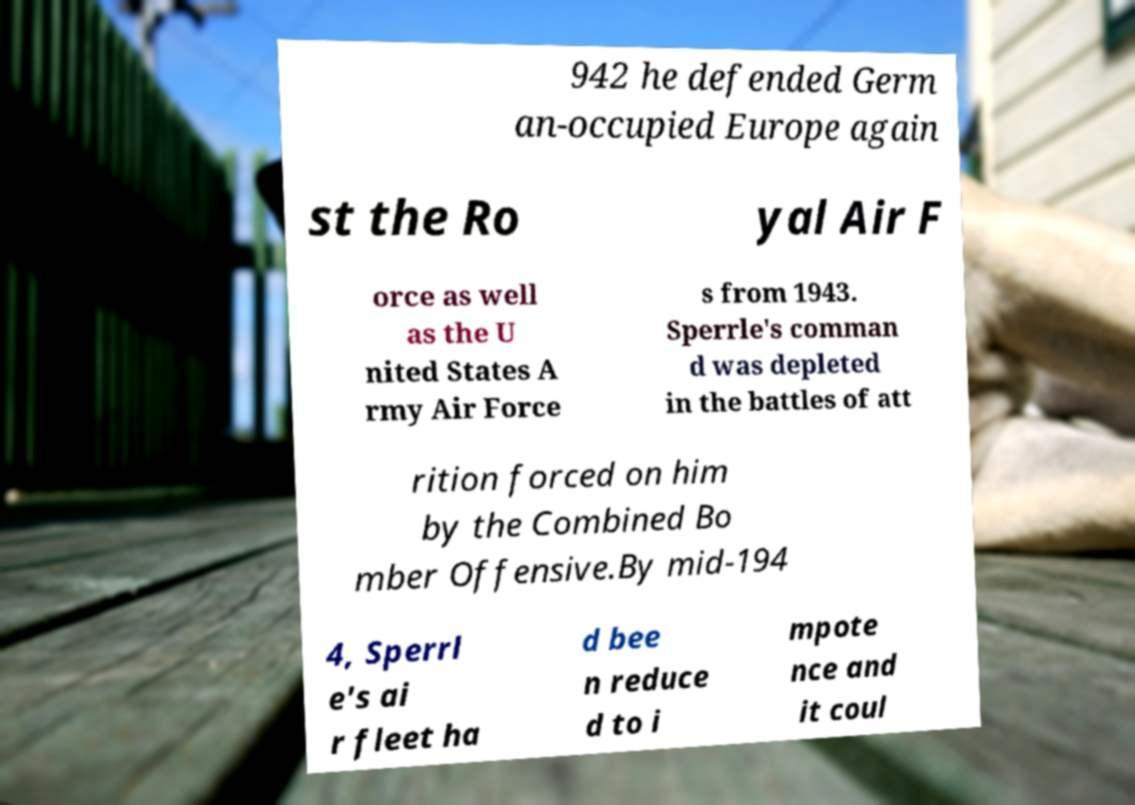I need the written content from this picture converted into text. Can you do that? 942 he defended Germ an-occupied Europe again st the Ro yal Air F orce as well as the U nited States A rmy Air Force s from 1943. Sperrle's comman d was depleted in the battles of att rition forced on him by the Combined Bo mber Offensive.By mid-194 4, Sperrl e's ai r fleet ha d bee n reduce d to i mpote nce and it coul 